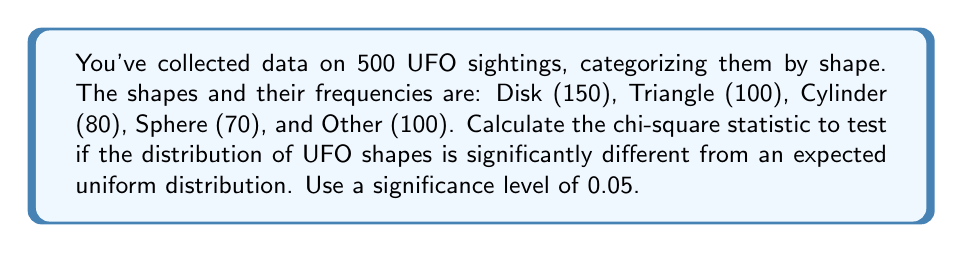Provide a solution to this math problem. 1) First, let's calculate the expected frequency for each category under a uniform distribution:
   Expected frequency = Total observations / Number of categories
   $E = 500 / 5 = 100$

2) Now, we can set up our chi-square calculation:
   $$\chi^2 = \sum_{i=1}^{k} \frac{(O_i - E_i)^2}{E_i}$$
   Where $O_i$ is the observed frequency and $E_i$ is the expected frequency

3) Let's calculate for each category:
   Disk: $\frac{(150 - 100)^2}{100} = 25$
   Triangle: $\frac{(100 - 100)^2}{100} = 0$
   Cylinder: $\frac{(80 - 100)^2}{100} = 4$
   Sphere: $\frac{(70 - 100)^2}{100} = 9$
   Other: $\frac{(100 - 100)^2}{100} = 0$

4) Sum these values:
   $\chi^2 = 25 + 0 + 4 + 9 + 0 = 38$

5) Determine the degrees of freedom:
   df = number of categories - 1 = 5 - 1 = 4

6) For $\alpha = 0.05$ and df = 4, the critical value is 9.488

7) Since our calculated $\chi^2 (38)$ is greater than the critical value (9.488), we reject the null hypothesis.
Answer: $\chi^2 = 38$, reject null hypothesis 